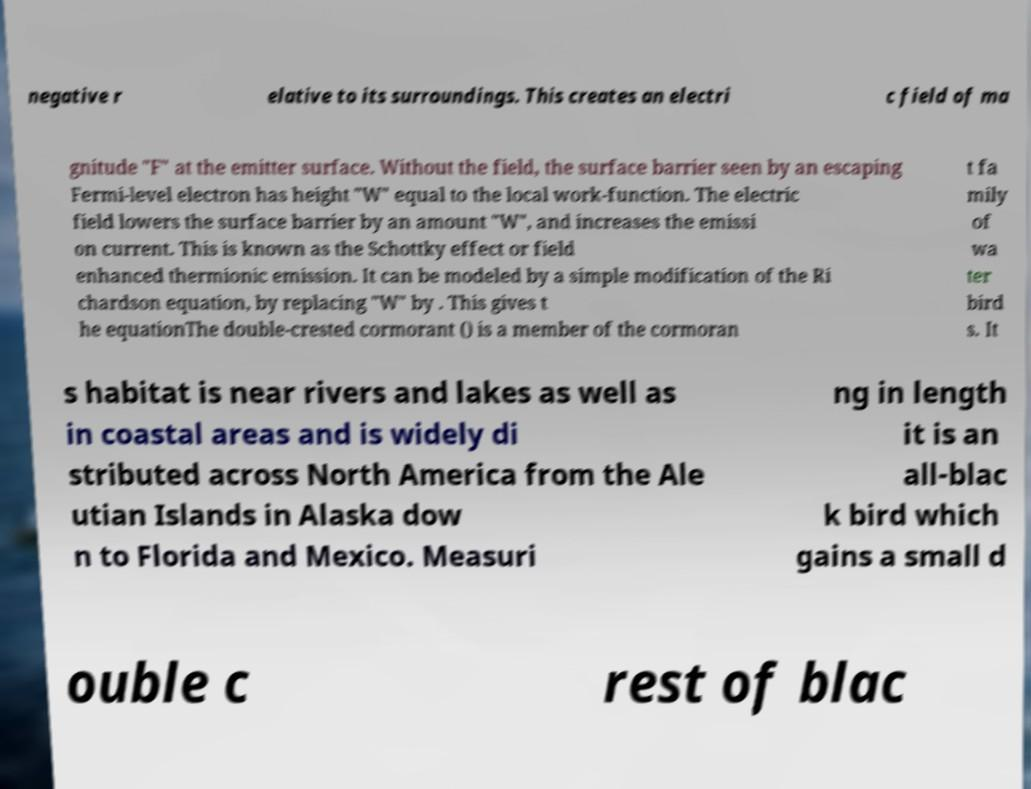Can you accurately transcribe the text from the provided image for me? negative r elative to its surroundings. This creates an electri c field of ma gnitude "F" at the emitter surface. Without the field, the surface barrier seen by an escaping Fermi-level electron has height "W" equal to the local work-function. The electric field lowers the surface barrier by an amount "W", and increases the emissi on current. This is known as the Schottky effect or field enhanced thermionic emission. It can be modeled by a simple modification of the Ri chardson equation, by replacing "W" by . This gives t he equationThe double-crested cormorant () is a member of the cormoran t fa mily of wa ter bird s. It s habitat is near rivers and lakes as well as in coastal areas and is widely di stributed across North America from the Ale utian Islands in Alaska dow n to Florida and Mexico. Measuri ng in length it is an all-blac k bird which gains a small d ouble c rest of blac 